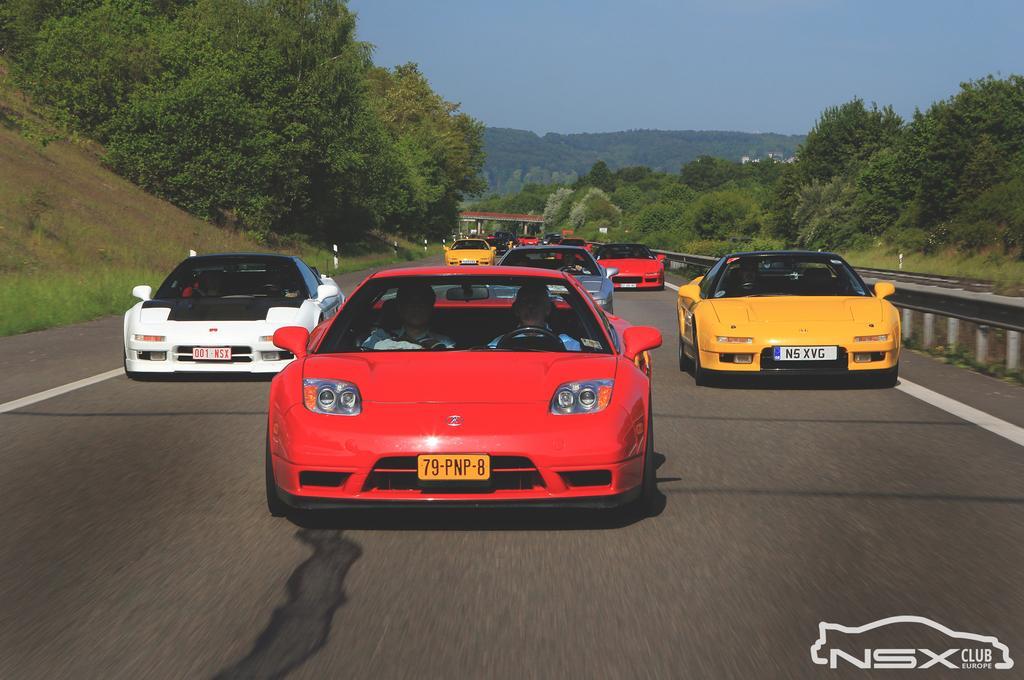Could you give a brief overview of what you see in this image? In the image there are few sport cars on the road with trees and plants on either side of it and above its sky. 